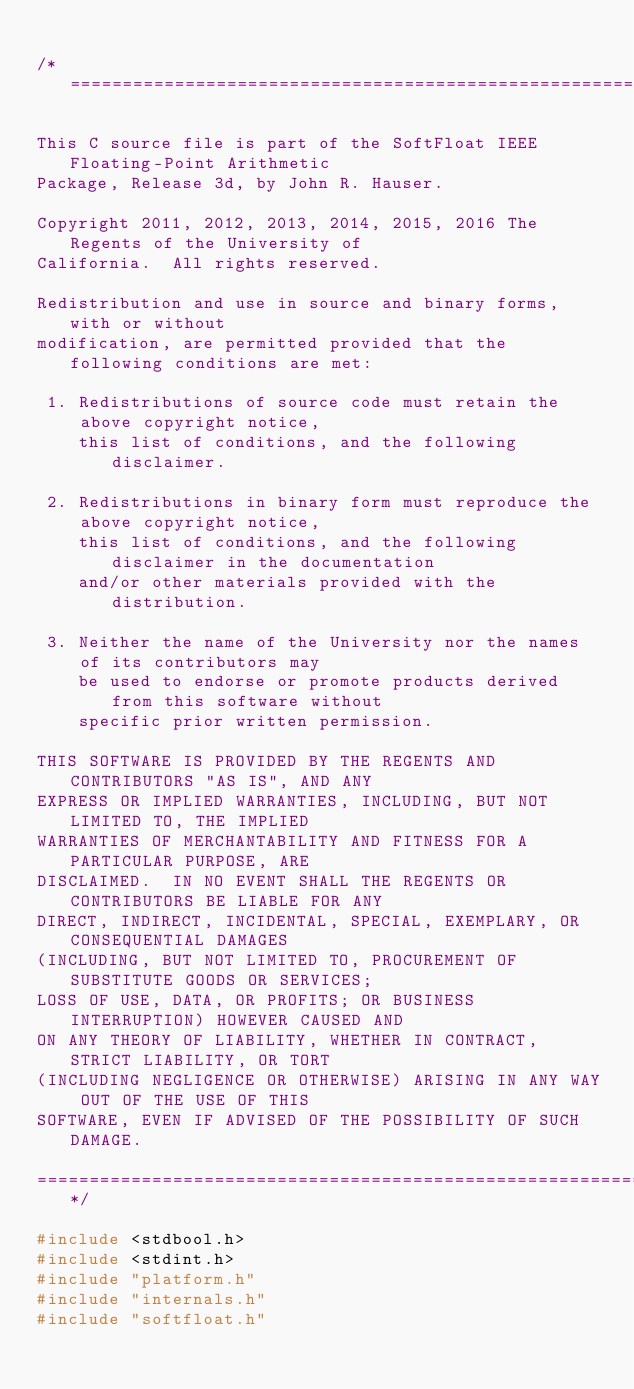Convert code to text. <code><loc_0><loc_0><loc_500><loc_500><_C_>
/*============================================================================

This C source file is part of the SoftFloat IEEE Floating-Point Arithmetic
Package, Release 3d, by John R. Hauser.

Copyright 2011, 2012, 2013, 2014, 2015, 2016 The Regents of the University of
California.  All rights reserved.

Redistribution and use in source and binary forms, with or without
modification, are permitted provided that the following conditions are met:

 1. Redistributions of source code must retain the above copyright notice,
    this list of conditions, and the following disclaimer.

 2. Redistributions in binary form must reproduce the above copyright notice,
    this list of conditions, and the following disclaimer in the documentation
    and/or other materials provided with the distribution.

 3. Neither the name of the University nor the names of its contributors may
    be used to endorse or promote products derived from this software without
    specific prior written permission.

THIS SOFTWARE IS PROVIDED BY THE REGENTS AND CONTRIBUTORS "AS IS", AND ANY
EXPRESS OR IMPLIED WARRANTIES, INCLUDING, BUT NOT LIMITED TO, THE IMPLIED
WARRANTIES OF MERCHANTABILITY AND FITNESS FOR A PARTICULAR PURPOSE, ARE
DISCLAIMED.  IN NO EVENT SHALL THE REGENTS OR CONTRIBUTORS BE LIABLE FOR ANY
DIRECT, INDIRECT, INCIDENTAL, SPECIAL, EXEMPLARY, OR CONSEQUENTIAL DAMAGES
(INCLUDING, BUT NOT LIMITED TO, PROCUREMENT OF SUBSTITUTE GOODS OR SERVICES;
LOSS OF USE, DATA, OR PROFITS; OR BUSINESS INTERRUPTION) HOWEVER CAUSED AND
ON ANY THEORY OF LIABILITY, WHETHER IN CONTRACT, STRICT LIABILITY, OR TORT
(INCLUDING NEGLIGENCE OR OTHERWISE) ARISING IN ANY WAY OUT OF THE USE OF THIS
SOFTWARE, EVEN IF ADVISED OF THE POSSIBILITY OF SUCH DAMAGE.

=============================================================================*/

#include <stdbool.h>
#include <stdint.h>
#include "platform.h"
#include "internals.h"
#include "softfloat.h"
</code> 